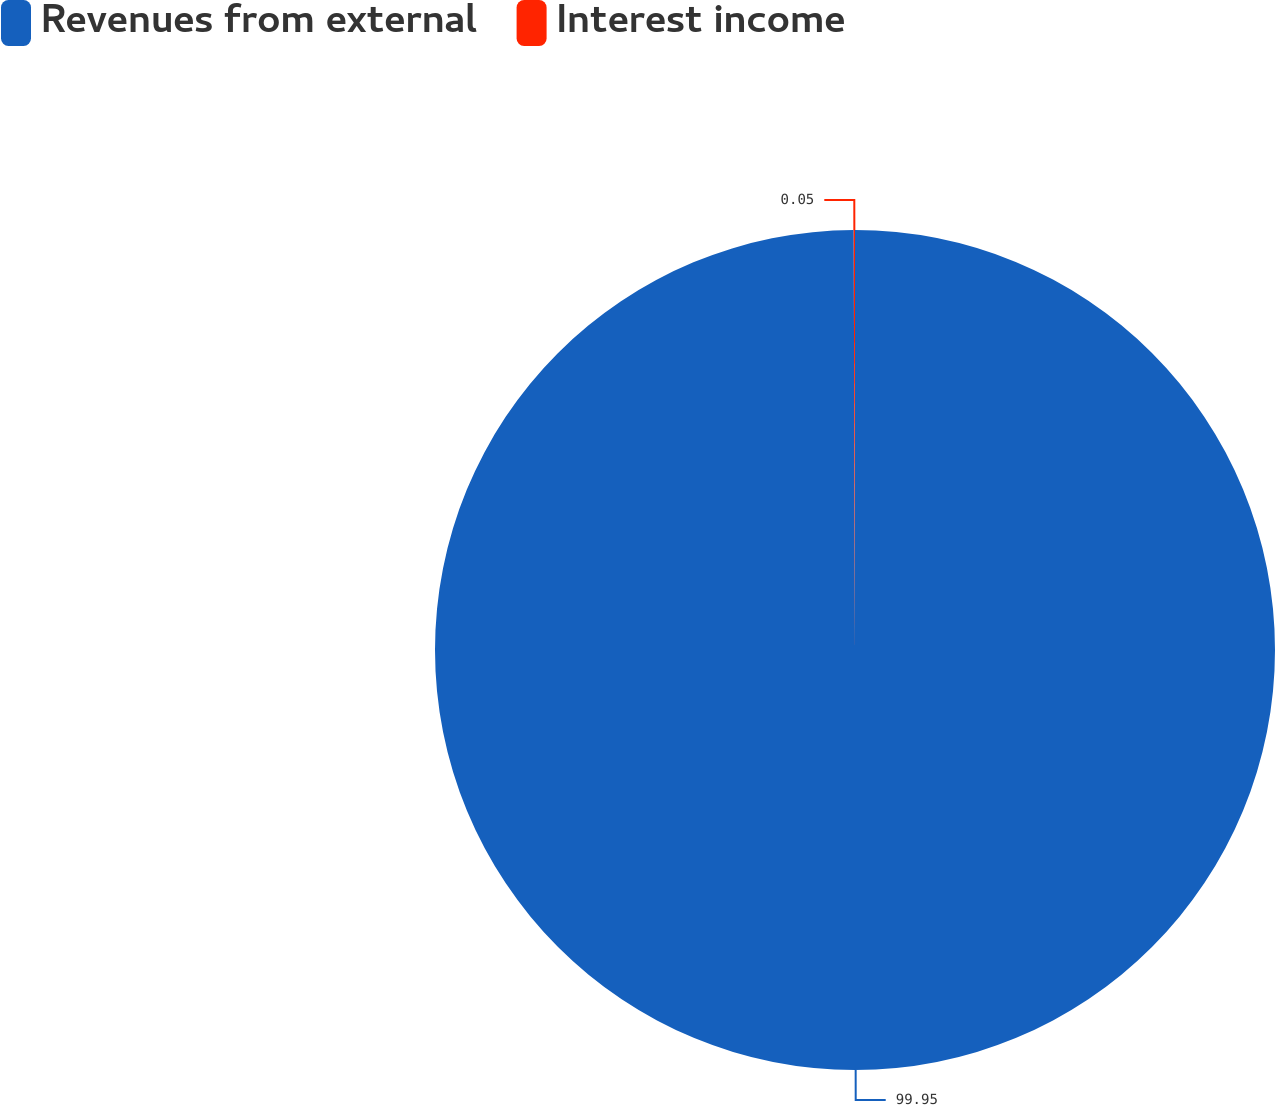Convert chart to OTSL. <chart><loc_0><loc_0><loc_500><loc_500><pie_chart><fcel>Revenues from external<fcel>Interest income<nl><fcel>99.95%<fcel>0.05%<nl></chart> 